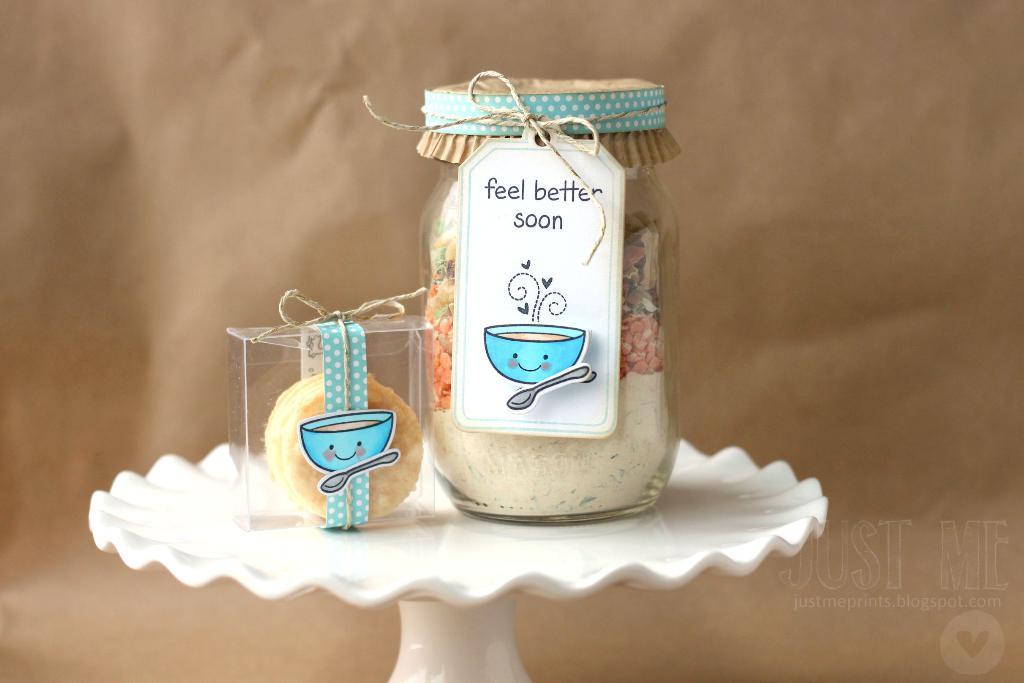What does this product hope you feel soon?
Ensure brevity in your answer.  Better. 